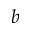<formula> <loc_0><loc_0><loc_500><loc_500>b</formula> 